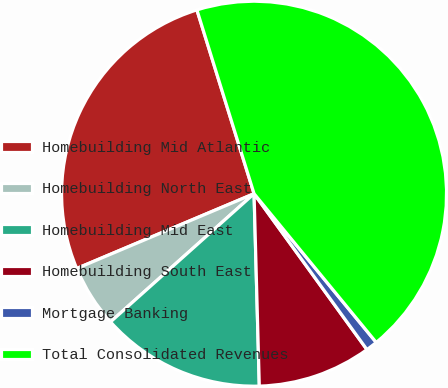Convert chart. <chart><loc_0><loc_0><loc_500><loc_500><pie_chart><fcel>Homebuilding Mid Atlantic<fcel>Homebuilding North East<fcel>Homebuilding Mid East<fcel>Homebuilding South East<fcel>Mortgage Banking<fcel>Total Consolidated Revenues<nl><fcel>26.55%<fcel>5.25%<fcel>13.83%<fcel>9.54%<fcel>0.97%<fcel>43.85%<nl></chart> 